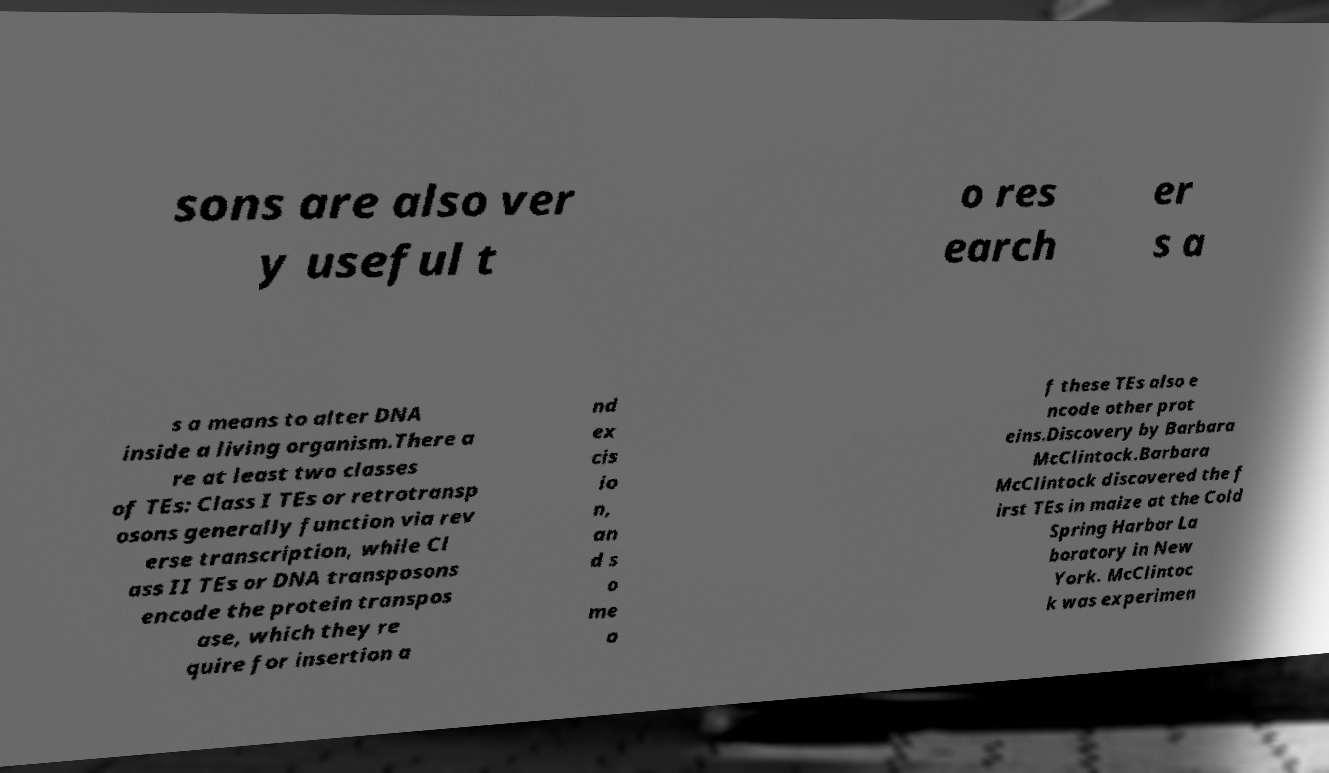I need the written content from this picture converted into text. Can you do that? sons are also ver y useful t o res earch er s a s a means to alter DNA inside a living organism.There a re at least two classes of TEs: Class I TEs or retrotransp osons generally function via rev erse transcription, while Cl ass II TEs or DNA transposons encode the protein transpos ase, which they re quire for insertion a nd ex cis io n, an d s o me o f these TEs also e ncode other prot eins.Discovery by Barbara McClintock.Barbara McClintock discovered the f irst TEs in maize at the Cold Spring Harbor La boratory in New York. McClintoc k was experimen 